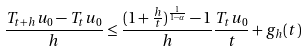Convert formula to latex. <formula><loc_0><loc_0><loc_500><loc_500>\frac { T _ { t + h } u _ { 0 } - T _ { t } u _ { 0 } } { h } \leq \frac { ( 1 + \frac { h } { t } ) ^ { \frac { 1 } { 1 - \alpha } } - 1 } { h } \frac { T _ { t } u _ { 0 } } { t } + g _ { h } ( t )</formula> 